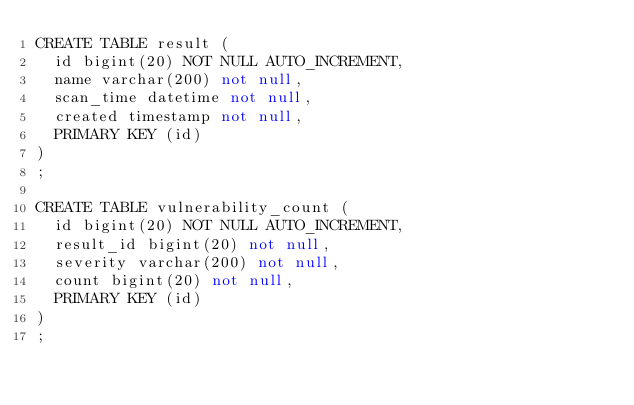Convert code to text. <code><loc_0><loc_0><loc_500><loc_500><_SQL_>CREATE TABLE result (
  id bigint(20) NOT NULL AUTO_INCREMENT,
  name varchar(200) not null,
  scan_time datetime not null,
  created timestamp not null,
  PRIMARY KEY (id)
)
;

CREATE TABLE vulnerability_count (
  id bigint(20) NOT NULL AUTO_INCREMENT,
  result_id bigint(20) not null,
  severity varchar(200) not null,
  count bigint(20) not null,
  PRIMARY KEY (id)
)
;
</code> 